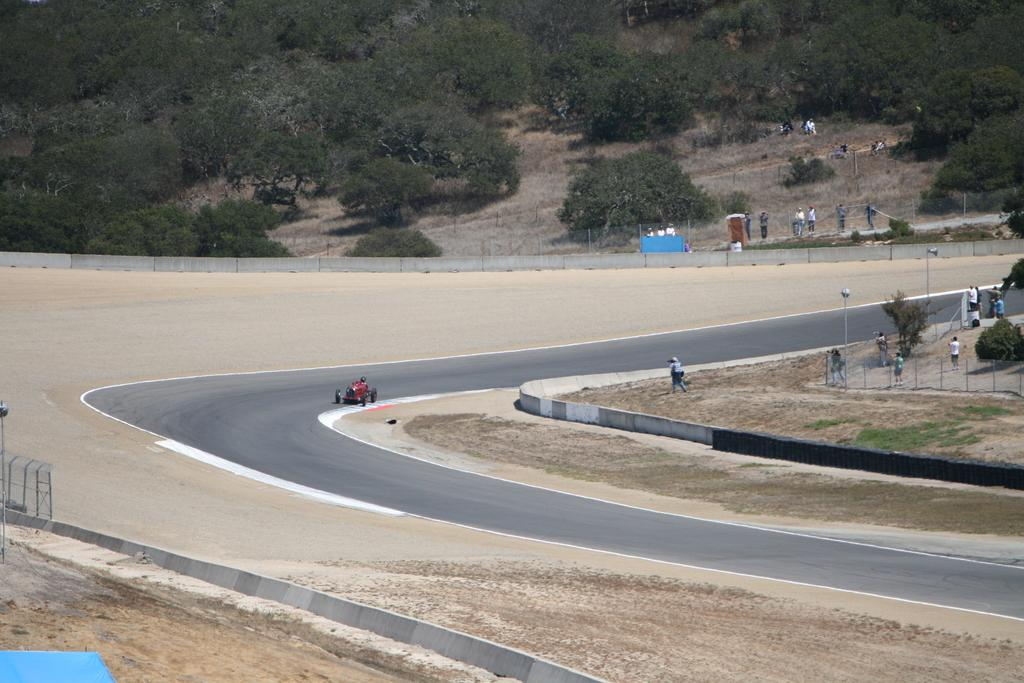How many people are in the image? There is a group of people in the image. What else can be seen on the road in the image? There is a vehicle on the road in the image. What structures are present in the image? There are poles and a fence in the image. What type of natural scenery is visible in the background of the image? There are trees in the background of the image. Can you tell me how many men are touching the vehicle in the image? There is no information about the gender of the people in the image, nor is there any indication that anyone is touching the vehicle. 